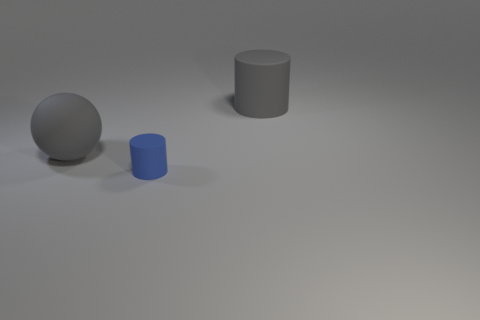Add 2 big matte objects. How many objects exist? 5 Subtract all cylinders. How many objects are left? 1 Subtract 0 brown cubes. How many objects are left? 3 Subtract all tiny rubber cylinders. Subtract all small blue cylinders. How many objects are left? 1 Add 2 large cylinders. How many large cylinders are left? 3 Add 2 tiny cyan spheres. How many tiny cyan spheres exist? 2 